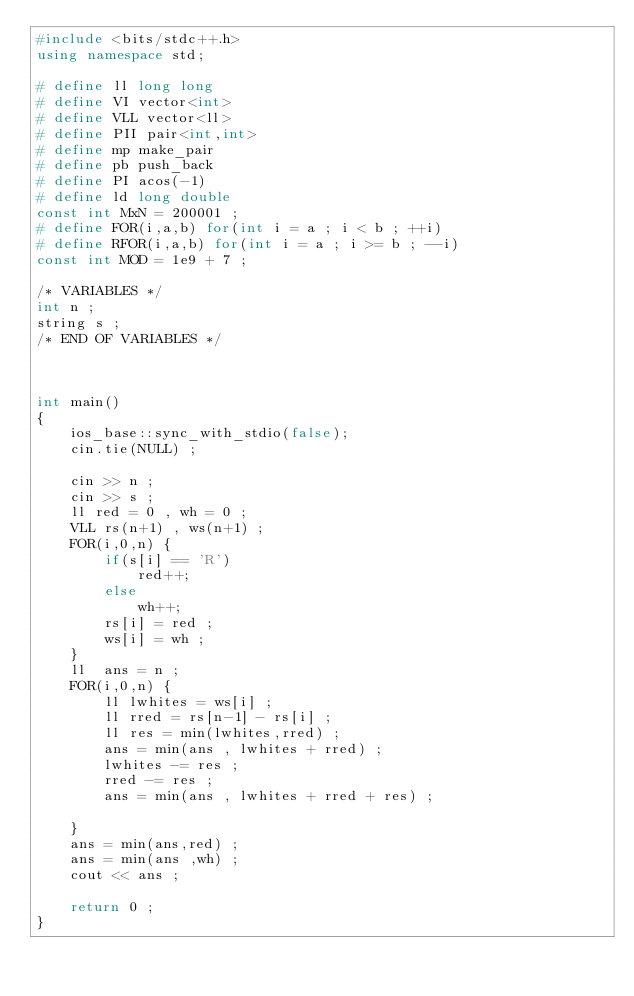Convert code to text. <code><loc_0><loc_0><loc_500><loc_500><_C++_>#include <bits/stdc++.h>
using namespace std;

# define ll long long 
# define VI vector<int>
# define VLL vector<ll>
# define PII pair<int,int> 
# define mp make_pair
# define pb push_back
# define PI acos(-1)
# define ld long double
const int MxN = 200001 ; 
# define FOR(i,a,b) for(int i = a ; i < b ; ++i)
# define RFOR(i,a,b) for(int i = a ; i >= b ; --i)
const int MOD = 1e9 + 7 ; 

/* VARIABLES */
int n ;  
string s ; 
/* END OF VARIABLES */



int main()
{
	ios_base::sync_with_stdio(false);
	cin.tie(NULL) ;  

	cin >> n ; 
	cin >> s ;
	ll red = 0 , wh = 0 ;  
	VLL rs(n+1) , ws(n+1) ; 
	FOR(i,0,n) {
		if(s[i] == 'R')
			red++;
		else 
			wh++;
		rs[i] = red ; 
		ws[i] = wh ; 
	}
	ll  ans = n ; 
	FOR(i,0,n) {
		ll lwhites = ws[i] ; 
		ll rred = rs[n-1] - rs[i] ; 
		ll res = min(lwhites,rred) ; 
		ans = min(ans , lwhites + rred) ; 
		lwhites -= res ; 
		rred -= res ; 
		ans = min(ans , lwhites + rred + res) ; 
		
	}
	ans = min(ans,red) ;
	ans = min(ans ,wh) ; 
	cout << ans ; 
	
	return 0 ; 
}

</code> 